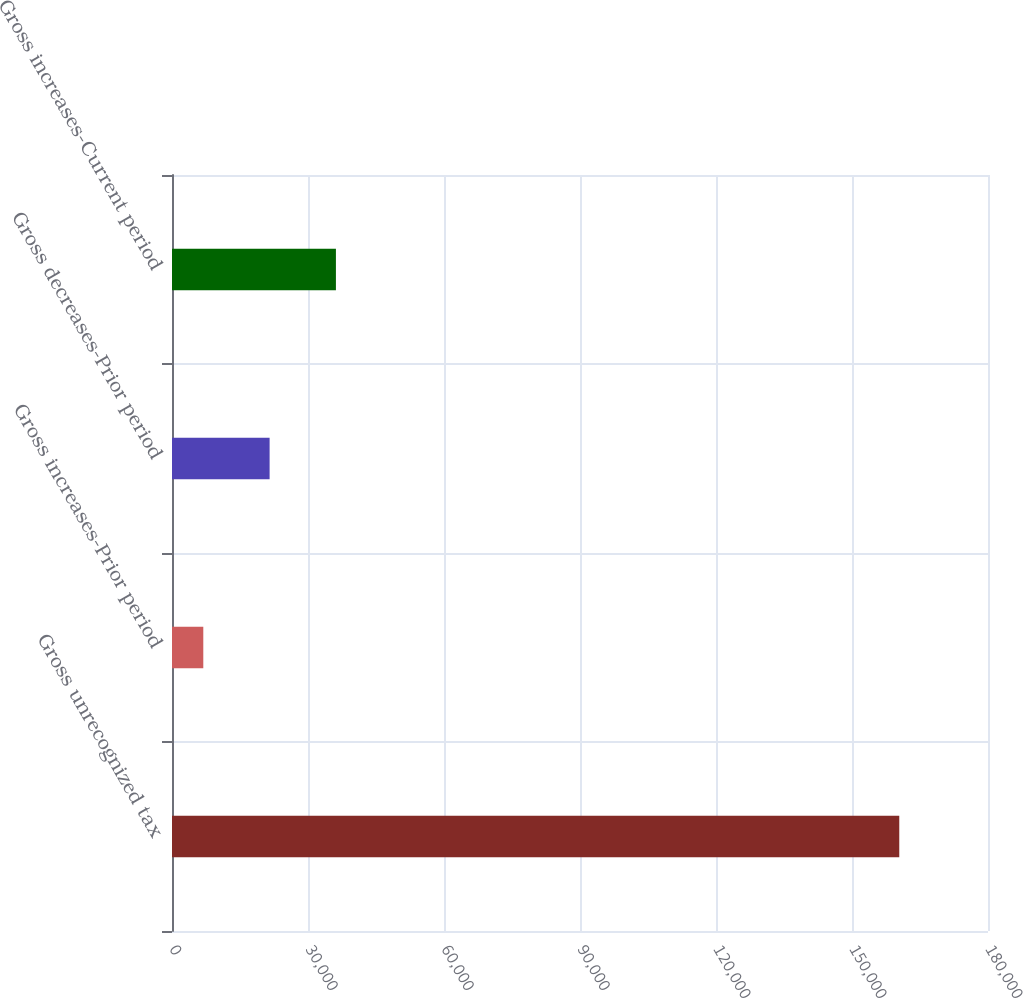<chart> <loc_0><loc_0><loc_500><loc_500><bar_chart><fcel>Gross unrecognized tax<fcel>Gross increases-Prior period<fcel>Gross decreases-Prior period<fcel>Gross increases-Current period<nl><fcel>160427<fcel>6903<fcel>21531.1<fcel>36159.2<nl></chart> 